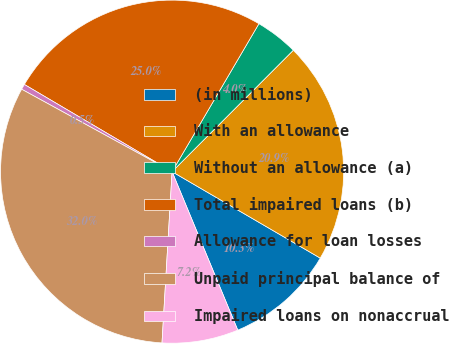Convert chart to OTSL. <chart><loc_0><loc_0><loc_500><loc_500><pie_chart><fcel>(in millions)<fcel>With an allowance<fcel>Without an allowance (a)<fcel>Total impaired loans (b)<fcel>Allowance for loan losses<fcel>Unpaid principal balance of<fcel>Impaired loans on nonaccrual<nl><fcel>10.34%<fcel>20.92%<fcel>4.04%<fcel>24.96%<fcel>0.51%<fcel>32.04%<fcel>7.19%<nl></chart> 